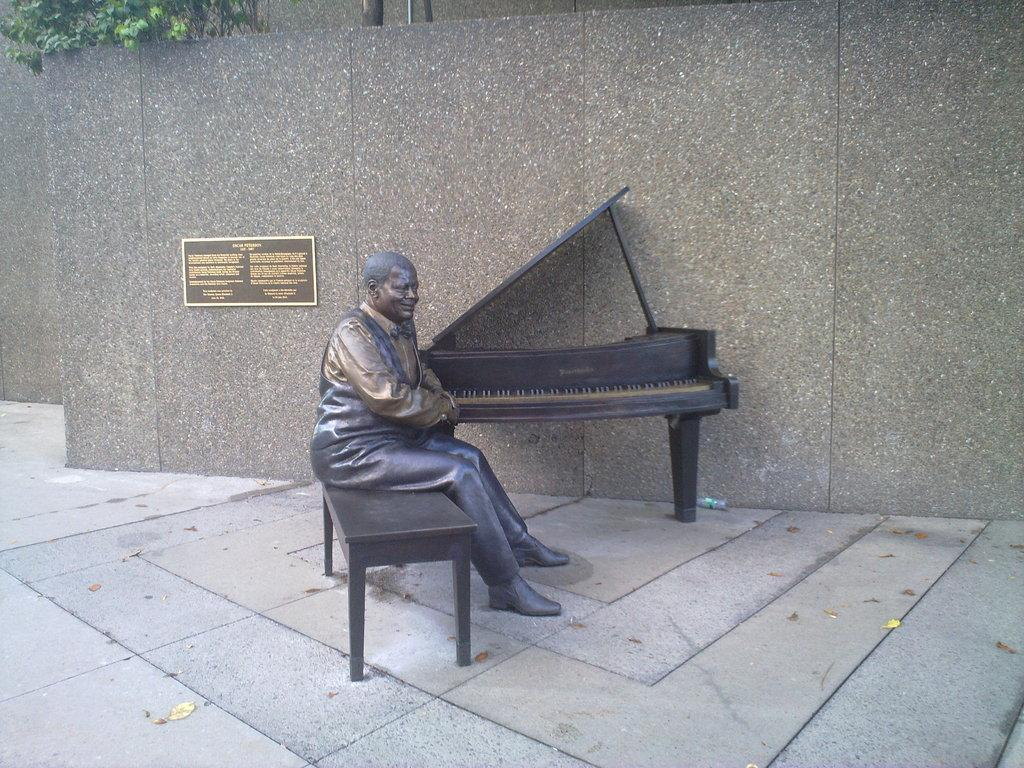What is the main subject in the image? There is a sculpture in the image. What is another object present in the image? There is a bench in the image. Are there any musical instruments in the image? Yes, there is a piano in the image. What can be seen in the background of the image? There is a wall, a board, and a tree in the background of the image. What type of shoes can be seen hanging on the tree in the image? There are no shoes present in the image; the tree is in the background and does not have any shoes hanging from it. 